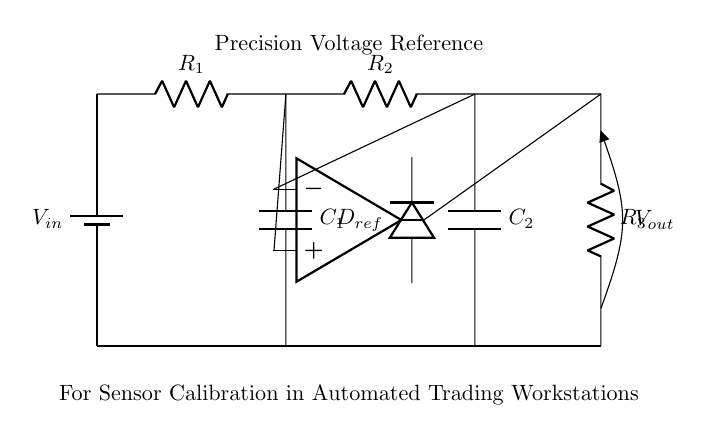What is the input voltage of this circuit? The input voltage is denoted by V in, which is the voltage source in the circuit diagram.
Answer: V in What are the values of the resistors in this circuit? The circuit has three resistors labeled R1, R2, and R3, but their specific values are not provided in the diagram, just their identifiers.
Answer: R1, R2, R3 What type of diode is used in this precision voltage reference circuit? The circuit employs a reference diode denoted as D ref, which is specifically designed for precision applications to provide a stable voltage.
Answer: D ref How many capacitors are present in the circuit? Upon inspecting the diagram, it is clear that there are two capacitors labeled C1 and C2.
Answer: 2 What is the function of the operational amplifier in this circuit? The operational amplifier in this circuit is used to enhance the voltage stability and precision, operating as a voltage follower or amplifier depending on the configuration.
Answer: Voltage amplification What is the output voltage of this circuit? The output voltage is labeled as V out in the diagram, which indicates the regulated voltage that is provided as an output from the circuit for calibration purposes.
Answer: V out What is the primary purpose of this precision voltage reference circuit? The primary purpose, as stated in the diagram, is for sensor calibration in automated trading workstations, indicating its specific application in enhancing measurement accuracy.
Answer: Sensor calibration 